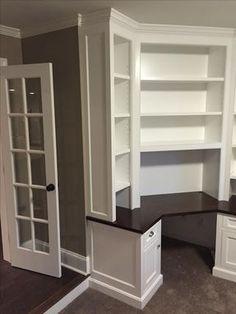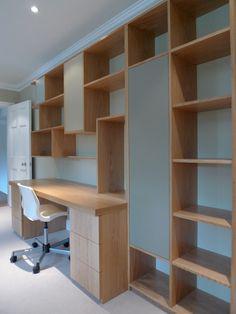The first image is the image on the left, the second image is the image on the right. Analyze the images presented: Is the assertion "In one of the images, there are built in bookcases attached to a bright orange wall." valid? Answer yes or no. No. The first image is the image on the left, the second image is the image on the right. Evaluate the accuracy of this statement regarding the images: "An image shows a white bookcase unit in front of a bright orange divider wall.". Is it true? Answer yes or no. No. 